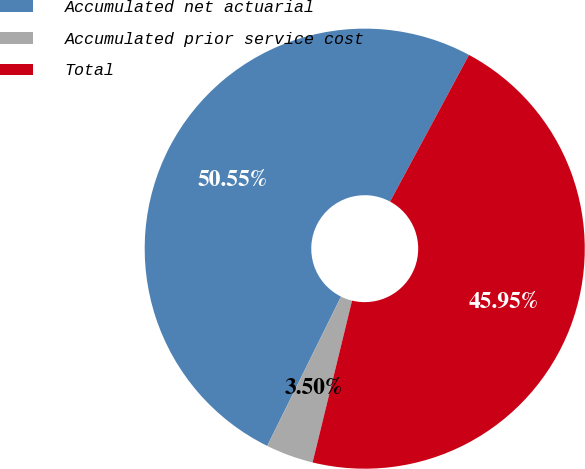Convert chart. <chart><loc_0><loc_0><loc_500><loc_500><pie_chart><fcel>Accumulated net actuarial<fcel>Accumulated prior service cost<fcel>Total<nl><fcel>50.55%<fcel>3.5%<fcel>45.95%<nl></chart> 